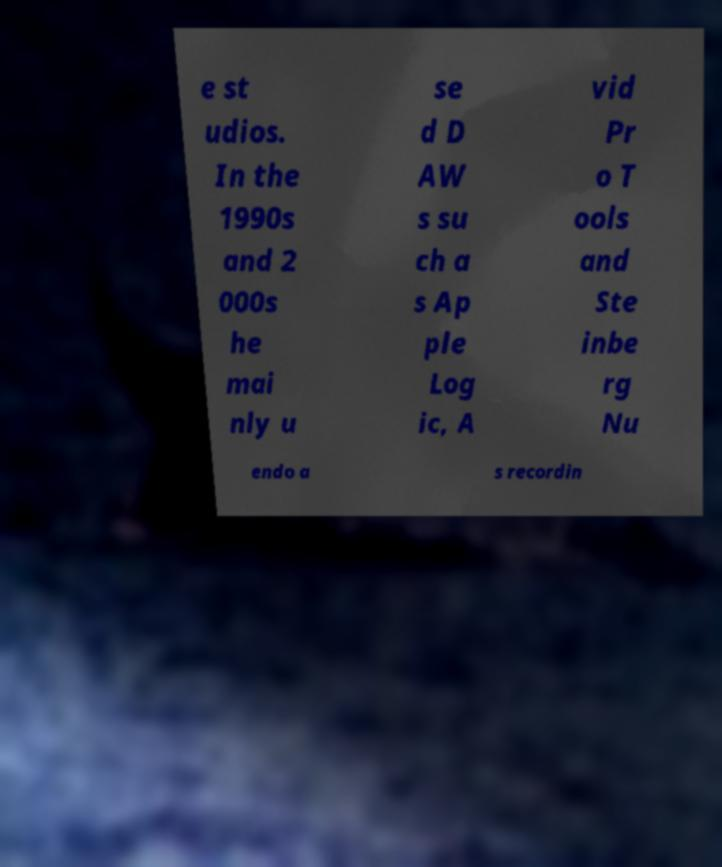There's text embedded in this image that I need extracted. Can you transcribe it verbatim? e st udios. In the 1990s and 2 000s he mai nly u se d D AW s su ch a s Ap ple Log ic, A vid Pr o T ools and Ste inbe rg Nu endo a s recordin 